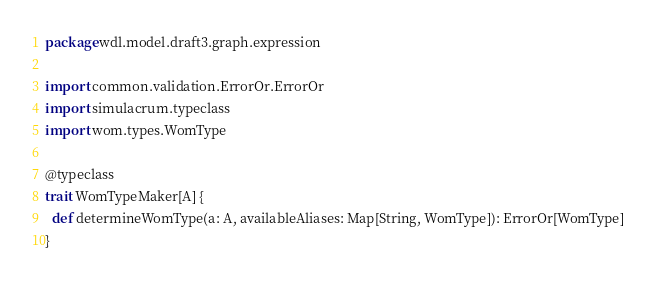Convert code to text. <code><loc_0><loc_0><loc_500><loc_500><_Scala_>package wdl.model.draft3.graph.expression

import common.validation.ErrorOr.ErrorOr
import simulacrum.typeclass
import wom.types.WomType

@typeclass
trait WomTypeMaker[A] {
  def determineWomType(a: A, availableAliases: Map[String, WomType]): ErrorOr[WomType]
}
</code> 